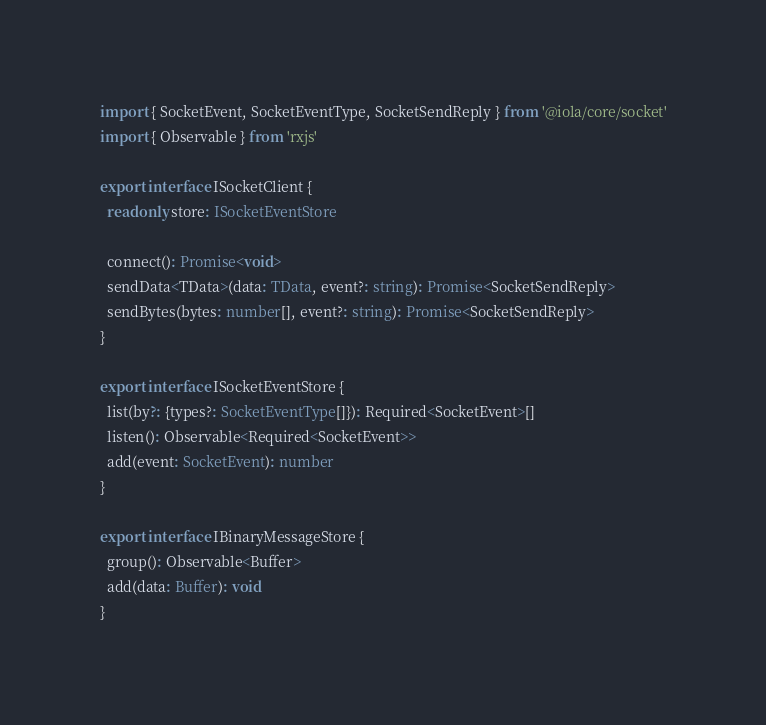<code> <loc_0><loc_0><loc_500><loc_500><_TypeScript_>import { SocketEvent, SocketEventType, SocketSendReply } from '@iola/core/socket'
import { Observable } from 'rxjs'

export interface ISocketClient {
  readonly store: ISocketEventStore

  connect(): Promise<void>
  sendData<TData>(data: TData, event?: string): Promise<SocketSendReply>
  sendBytes(bytes: number[], event?: string): Promise<SocketSendReply>
}

export interface ISocketEventStore {
  list(by?: {types?: SocketEventType[]}): Required<SocketEvent>[]
  listen(): Observable<Required<SocketEvent>>
  add(event: SocketEvent): number
}

export interface IBinaryMessageStore {
  group(): Observable<Buffer>
  add(data: Buffer): void
}

</code> 